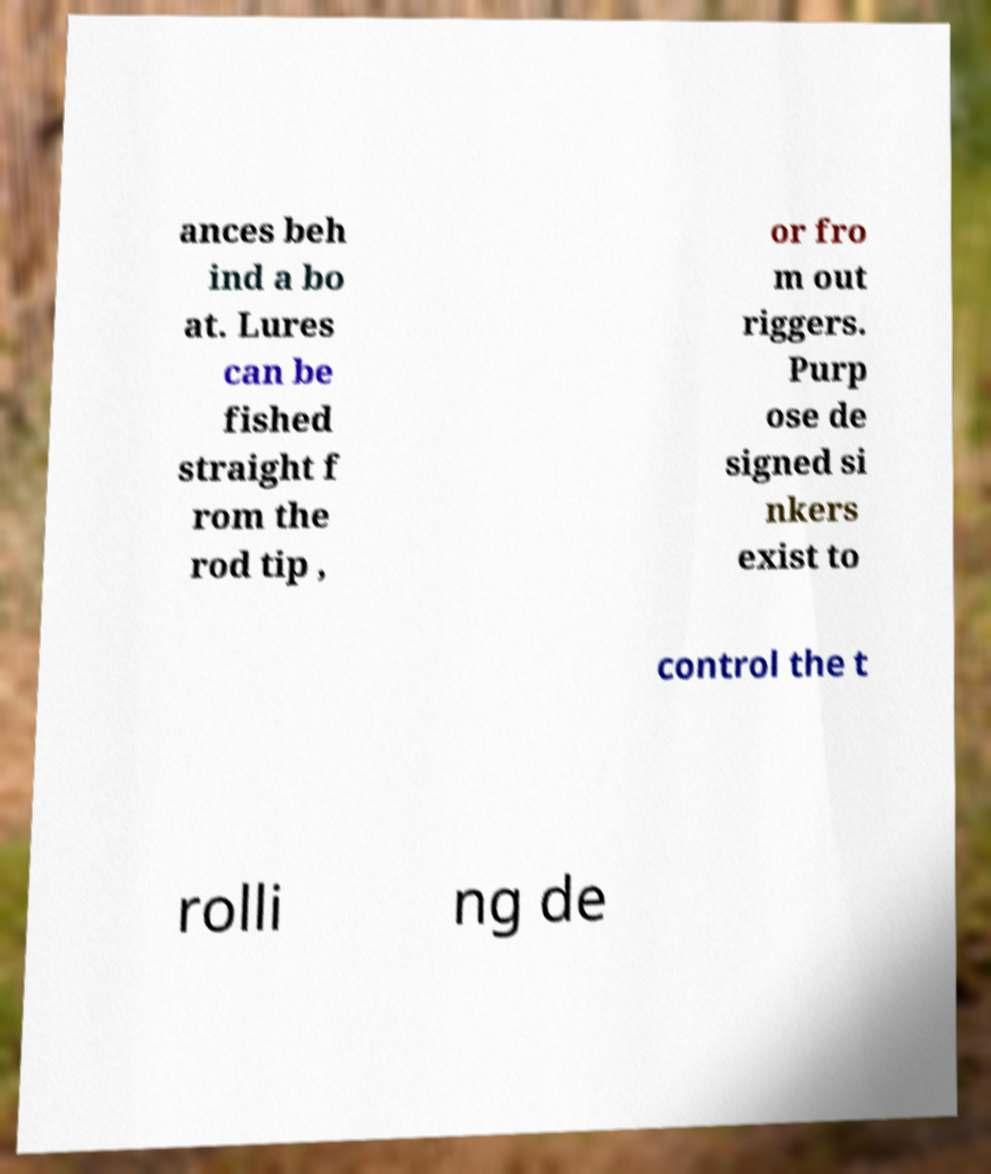Could you extract and type out the text from this image? ances beh ind a bo at. Lures can be fished straight f rom the rod tip , or fro m out riggers. Purp ose de signed si nkers exist to control the t rolli ng de 